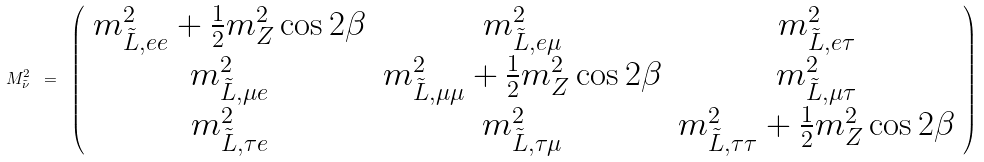Convert formula to latex. <formula><loc_0><loc_0><loc_500><loc_500>M _ { \tilde { \nu } } ^ { 2 } \ = \ \left ( \begin{array} { c c c } m _ { \tilde { L } , e e } ^ { 2 } + \frac { 1 } { 2 } m _ { Z } ^ { 2 } \cos 2 \beta & m _ { \tilde { L } , e \mu } ^ { 2 } & m _ { \tilde { L } , e \tau } ^ { 2 } \\ m _ { \tilde { L } , \mu e } ^ { 2 } & m _ { \tilde { L } , \mu \mu } ^ { 2 } + \frac { 1 } { 2 } m _ { Z } ^ { 2 } \cos 2 \beta & m _ { \tilde { L } , \mu \tau } ^ { 2 } \\ m _ { \tilde { L } , \tau e } ^ { 2 } & m _ { \tilde { L } , \tau \mu } ^ { 2 } & m _ { \tilde { L } , \tau \tau } ^ { 2 } + \frac { 1 } { 2 } m _ { Z } ^ { 2 } \cos 2 \beta \end{array} \right )</formula> 